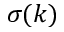<formula> <loc_0><loc_0><loc_500><loc_500>\sigma ( k )</formula> 